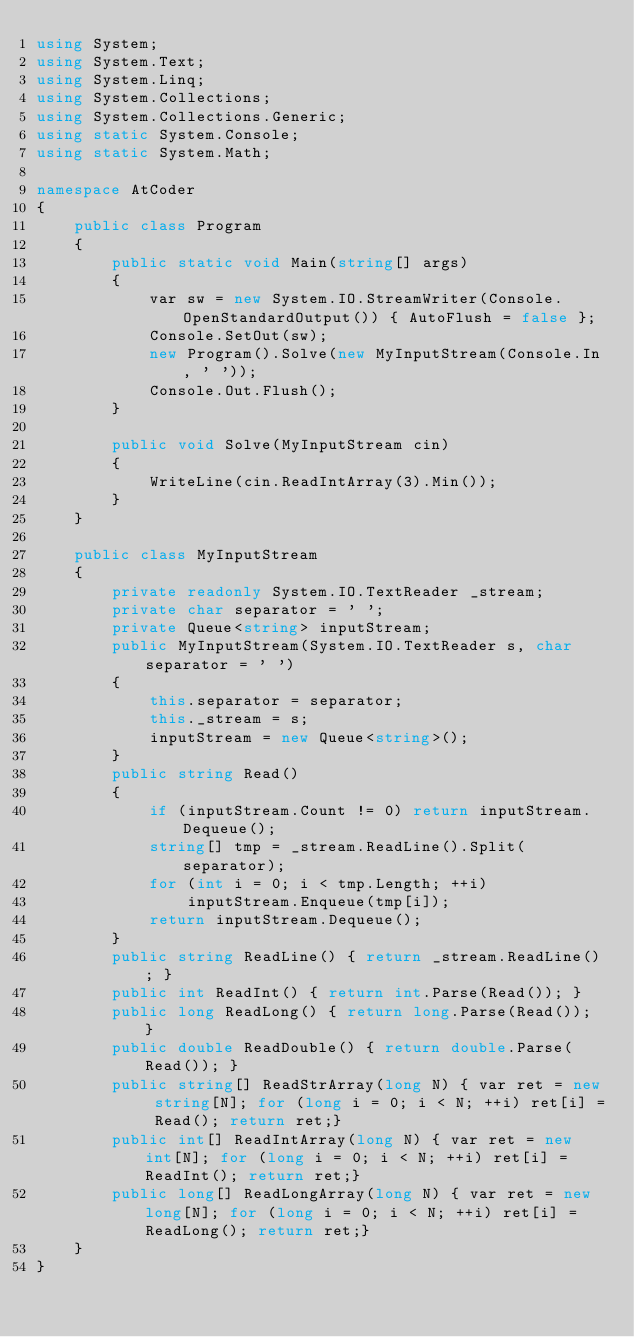<code> <loc_0><loc_0><loc_500><loc_500><_C#_>using System;
using System.Text;
using System.Linq;
using System.Collections;
using System.Collections.Generic;
using static System.Console;
using static System.Math;

namespace AtCoder
{
    public class Program
    {
        public static void Main(string[] args)
        {
            var sw = new System.IO.StreamWriter(Console.OpenStandardOutput()) { AutoFlush = false };
            Console.SetOut(sw);
            new Program().Solve(new MyInputStream(Console.In, ' '));
            Console.Out.Flush();
        }

        public void Solve(MyInputStream cin)
        {
            WriteLine(cin.ReadIntArray(3).Min());
        }
    }

    public class MyInputStream
    {
        private readonly System.IO.TextReader _stream;
        private char separator = ' ';
        private Queue<string> inputStream;
        public MyInputStream(System.IO.TextReader s, char separator = ' ')
        {
            this.separator = separator;
            this._stream = s;
            inputStream = new Queue<string>();
        }
        public string Read()
        {
            if (inputStream.Count != 0) return inputStream.Dequeue();
            string[] tmp = _stream.ReadLine().Split(separator);
            for (int i = 0; i < tmp.Length; ++i)
                inputStream.Enqueue(tmp[i]);
            return inputStream.Dequeue();
        }
        public string ReadLine() { return _stream.ReadLine(); }
        public int ReadInt() { return int.Parse(Read()); }
        public long ReadLong() { return long.Parse(Read()); }
        public double ReadDouble() { return double.Parse(Read()); }
        public string[] ReadStrArray(long N) { var ret = new string[N]; for (long i = 0; i < N; ++i) ret[i] = Read(); return ret;}
        public int[] ReadIntArray(long N) { var ret = new int[N]; for (long i = 0; i < N; ++i) ret[i] = ReadInt(); return ret;}
        public long[] ReadLongArray(long N) { var ret = new long[N]; for (long i = 0; i < N; ++i) ret[i] = ReadLong(); return ret;}
    }
}

</code> 